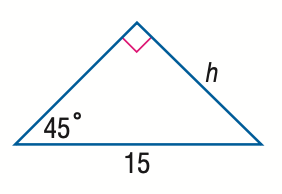Question: Find h in the triangle.
Choices:
A. \frac { 15 \sqrt 2 } { 3 }
B. \frac { 15 } { 2 }
C. \frac { 15 \sqrt 2 } { 2 }
D. 15
Answer with the letter. Answer: C 